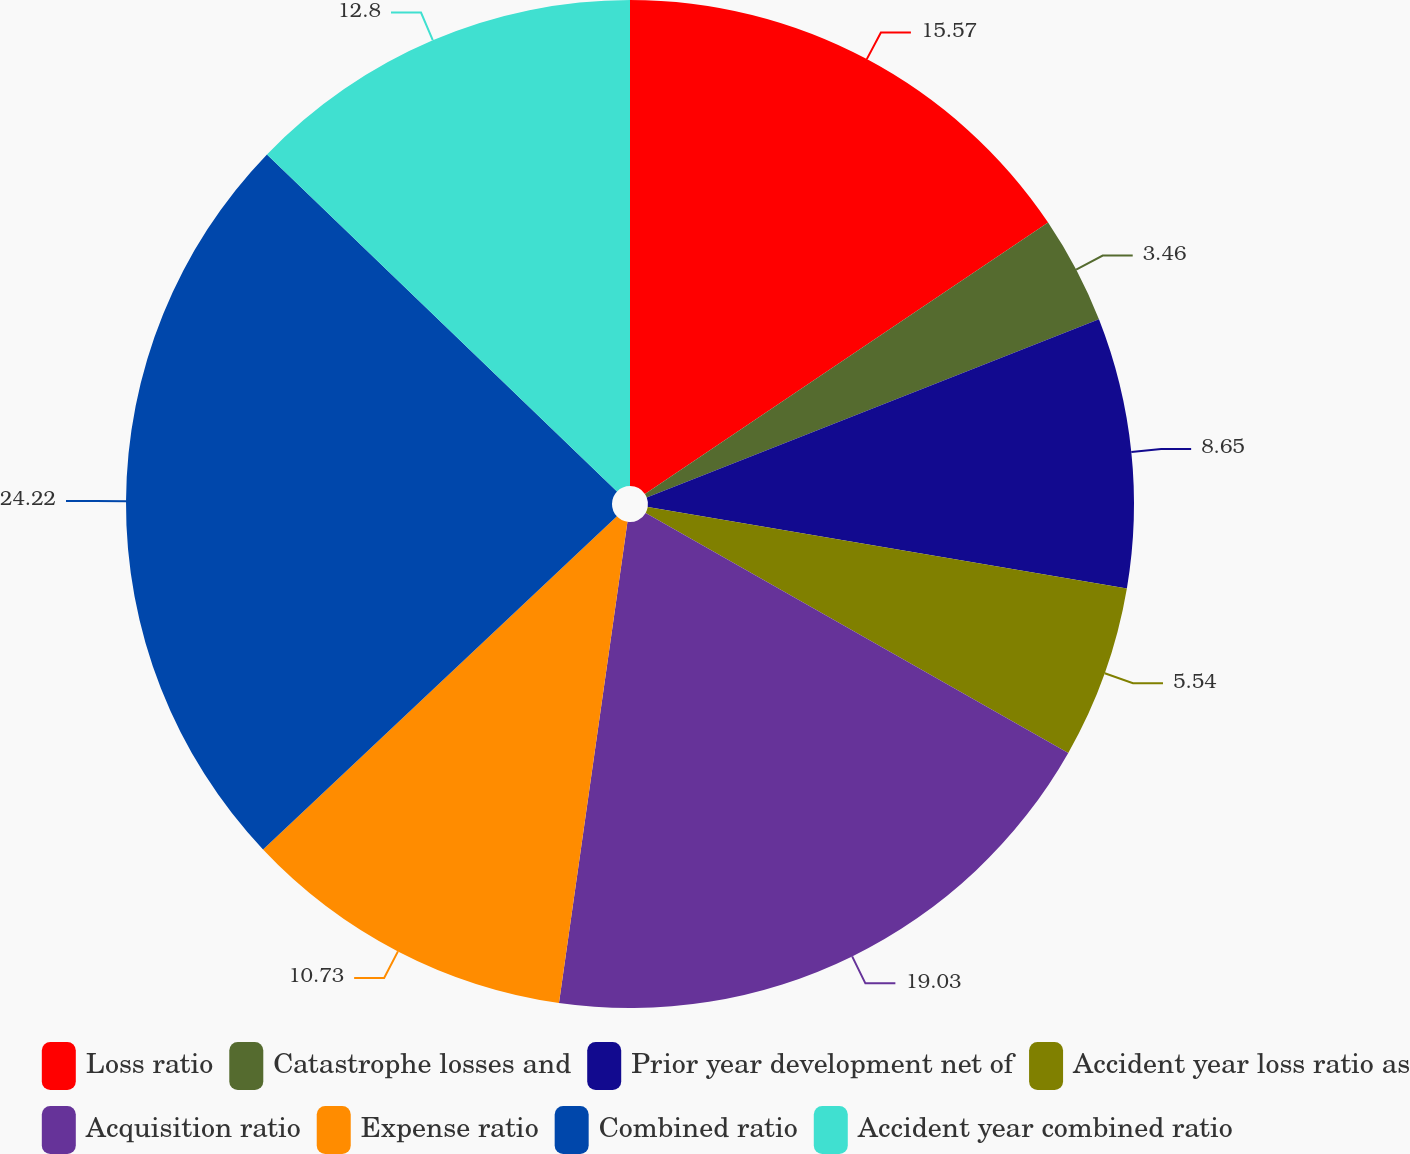Convert chart. <chart><loc_0><loc_0><loc_500><loc_500><pie_chart><fcel>Loss ratio<fcel>Catastrophe losses and<fcel>Prior year development net of<fcel>Accident year loss ratio as<fcel>Acquisition ratio<fcel>Expense ratio<fcel>Combined ratio<fcel>Accident year combined ratio<nl><fcel>15.57%<fcel>3.46%<fcel>8.65%<fcel>5.54%<fcel>19.03%<fcel>10.73%<fcel>24.22%<fcel>12.8%<nl></chart> 